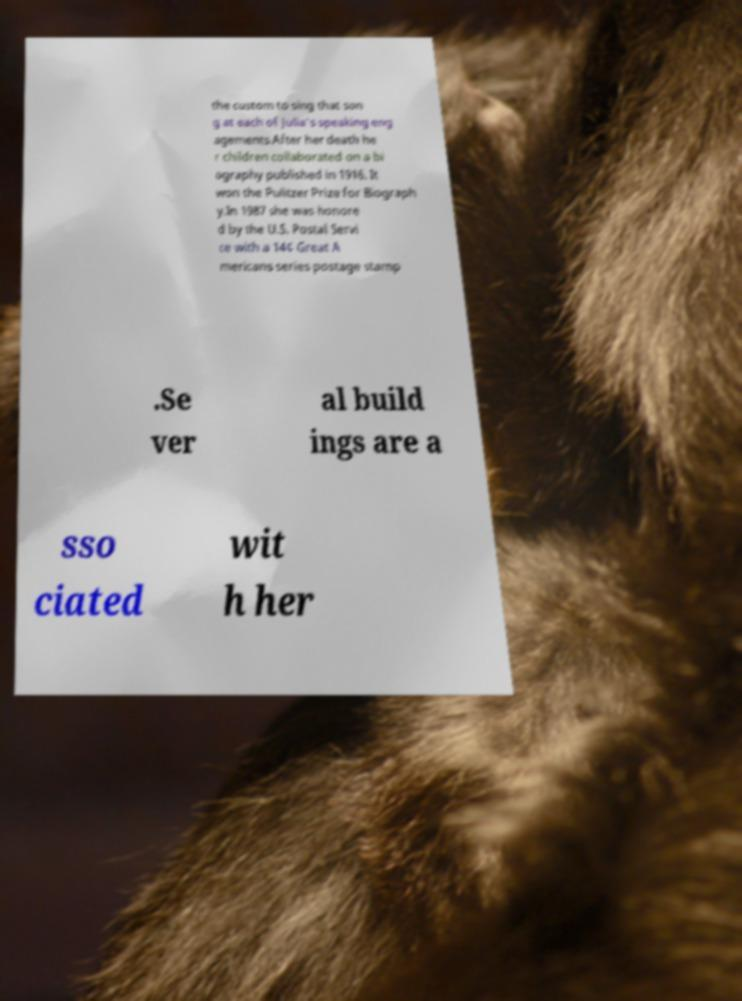For documentation purposes, I need the text within this image transcribed. Could you provide that? the custom to sing that son g at each of Julia's speaking eng agements.After her death he r children collaborated on a bi ography published in 1916. It won the Pulitzer Prize for Biograph y.In 1987 she was honore d by the U.S. Postal Servi ce with a 14¢ Great A mericans series postage stamp .Se ver al build ings are a sso ciated wit h her 